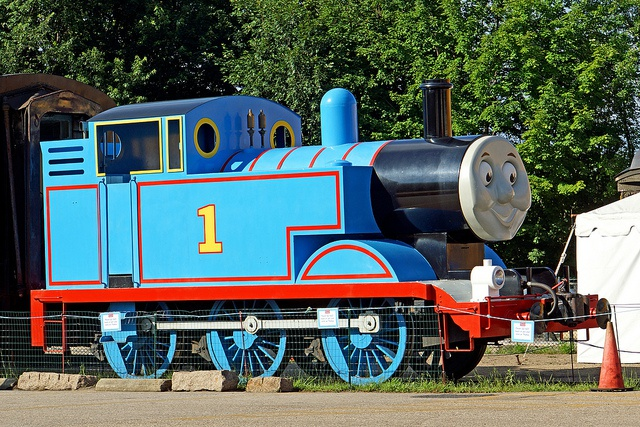Describe the objects in this image and their specific colors. I can see a train in olive, black, lightblue, blue, and red tones in this image. 